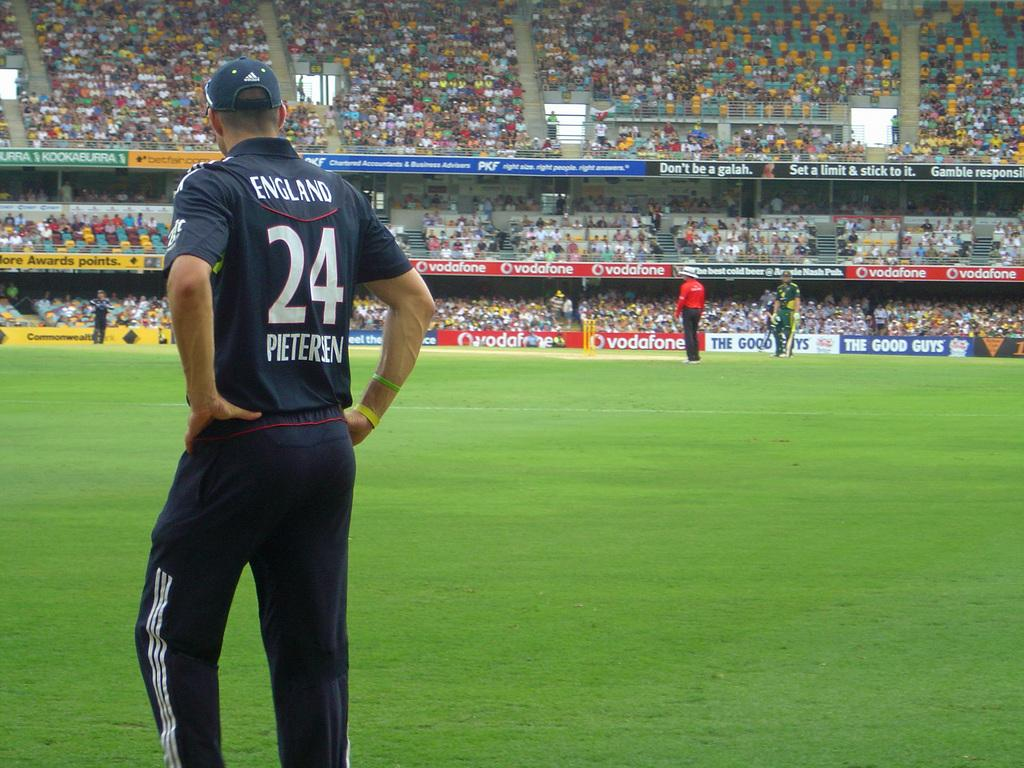<image>
Summarize the visual content of the image. A person wearing a Pietersen jersey stands looking out at a field. 